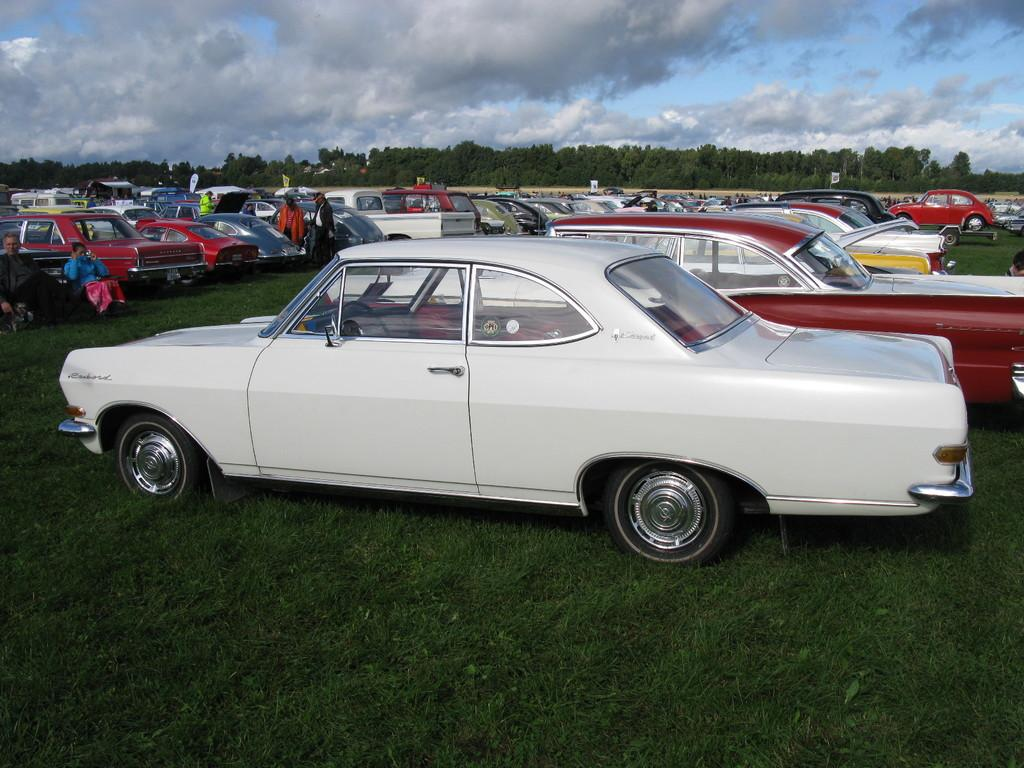What are the people in the image doing? There are people standing and sitting on a bench in the image. What type of vegetation is present in the image? There are trees and grass in the image. What is the condition of the sky in the image? The sky is cloudy in the image. What object can be seen in the image besides the people and vegetation? There is a board in the image. What type of sugar is being used to sweeten the coal in the image? There is no sugar or coal present in the image. What type of linen is draped over the trees in the image? There is no linen draped over the trees in the image; only trees, grass, and a board are present. 